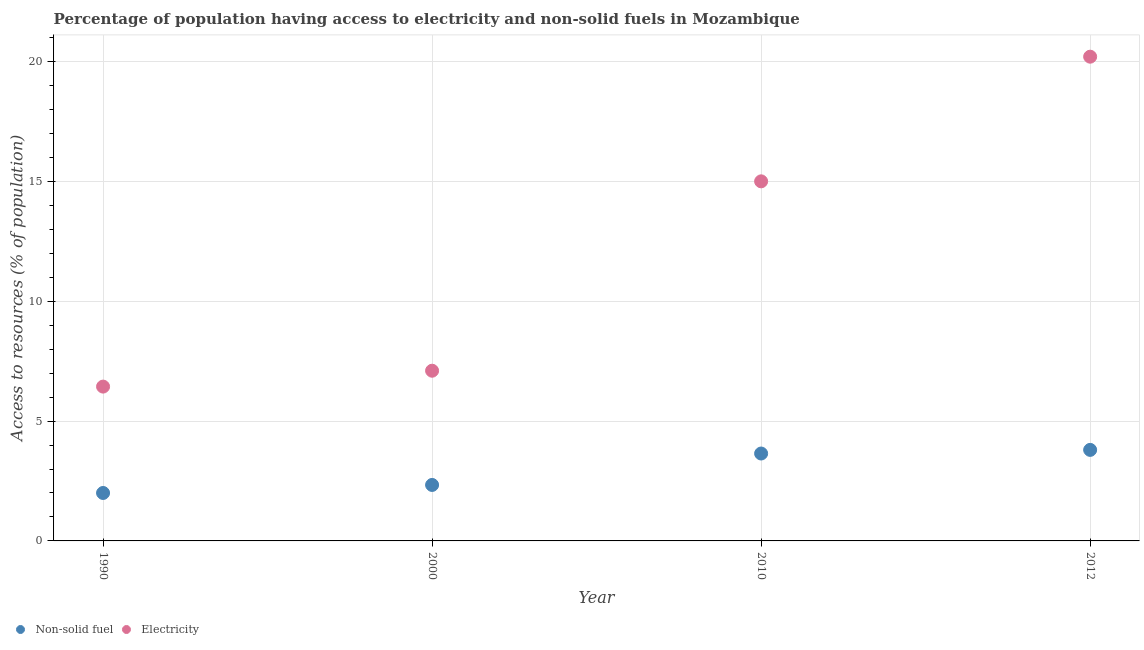Is the number of dotlines equal to the number of legend labels?
Give a very brief answer. Yes. What is the percentage of population having access to electricity in 2010?
Offer a terse response. 15. Across all years, what is the maximum percentage of population having access to electricity?
Offer a very short reply. 20.2. Across all years, what is the minimum percentage of population having access to electricity?
Offer a terse response. 6.44. In which year was the percentage of population having access to non-solid fuel minimum?
Your answer should be very brief. 1990. What is the total percentage of population having access to non-solid fuel in the graph?
Provide a short and direct response. 11.78. What is the difference between the percentage of population having access to electricity in 1990 and that in 2010?
Your answer should be compact. -8.56. What is the difference between the percentage of population having access to non-solid fuel in 1990 and the percentage of population having access to electricity in 2000?
Your answer should be very brief. -5.1. What is the average percentage of population having access to electricity per year?
Your answer should be very brief. 12.18. In the year 1990, what is the difference between the percentage of population having access to electricity and percentage of population having access to non-solid fuel?
Ensure brevity in your answer.  4.44. What is the ratio of the percentage of population having access to electricity in 2000 to that in 2012?
Offer a very short reply. 0.35. What is the difference between the highest and the second highest percentage of population having access to electricity?
Ensure brevity in your answer.  5.2. What is the difference between the highest and the lowest percentage of population having access to electricity?
Your answer should be compact. 13.76. In how many years, is the percentage of population having access to non-solid fuel greater than the average percentage of population having access to non-solid fuel taken over all years?
Your answer should be compact. 2. Does the percentage of population having access to non-solid fuel monotonically increase over the years?
Keep it short and to the point. Yes. Is the percentage of population having access to electricity strictly greater than the percentage of population having access to non-solid fuel over the years?
Provide a short and direct response. Yes. How many dotlines are there?
Ensure brevity in your answer.  2. How many years are there in the graph?
Provide a short and direct response. 4. Does the graph contain any zero values?
Make the answer very short. No. Does the graph contain grids?
Your response must be concise. Yes. What is the title of the graph?
Offer a terse response. Percentage of population having access to electricity and non-solid fuels in Mozambique. Does "Female entrants" appear as one of the legend labels in the graph?
Make the answer very short. No. What is the label or title of the X-axis?
Make the answer very short. Year. What is the label or title of the Y-axis?
Ensure brevity in your answer.  Access to resources (% of population). What is the Access to resources (% of population) in Non-solid fuel in 1990?
Offer a very short reply. 2. What is the Access to resources (% of population) of Electricity in 1990?
Ensure brevity in your answer.  6.44. What is the Access to resources (% of population) in Non-solid fuel in 2000?
Offer a terse response. 2.34. What is the Access to resources (% of population) of Electricity in 2000?
Offer a very short reply. 7.1. What is the Access to resources (% of population) of Non-solid fuel in 2010?
Offer a terse response. 3.65. What is the Access to resources (% of population) in Electricity in 2010?
Your response must be concise. 15. What is the Access to resources (% of population) in Non-solid fuel in 2012?
Offer a terse response. 3.8. What is the Access to resources (% of population) in Electricity in 2012?
Your answer should be very brief. 20.2. Across all years, what is the maximum Access to resources (% of population) in Non-solid fuel?
Offer a very short reply. 3.8. Across all years, what is the maximum Access to resources (% of population) in Electricity?
Provide a short and direct response. 20.2. Across all years, what is the minimum Access to resources (% of population) in Non-solid fuel?
Ensure brevity in your answer.  2. Across all years, what is the minimum Access to resources (% of population) in Electricity?
Your response must be concise. 6.44. What is the total Access to resources (% of population) of Non-solid fuel in the graph?
Provide a succinct answer. 11.78. What is the total Access to resources (% of population) in Electricity in the graph?
Ensure brevity in your answer.  48.74. What is the difference between the Access to resources (% of population) of Non-solid fuel in 1990 and that in 2000?
Give a very brief answer. -0.34. What is the difference between the Access to resources (% of population) in Electricity in 1990 and that in 2000?
Provide a succinct answer. -0.66. What is the difference between the Access to resources (% of population) of Non-solid fuel in 1990 and that in 2010?
Your answer should be compact. -1.65. What is the difference between the Access to resources (% of population) in Electricity in 1990 and that in 2010?
Make the answer very short. -8.56. What is the difference between the Access to resources (% of population) in Non-solid fuel in 1990 and that in 2012?
Offer a terse response. -1.8. What is the difference between the Access to resources (% of population) in Electricity in 1990 and that in 2012?
Your response must be concise. -13.76. What is the difference between the Access to resources (% of population) in Non-solid fuel in 2000 and that in 2010?
Your response must be concise. -1.31. What is the difference between the Access to resources (% of population) in Electricity in 2000 and that in 2010?
Your answer should be compact. -7.9. What is the difference between the Access to resources (% of population) of Non-solid fuel in 2000 and that in 2012?
Keep it short and to the point. -1.46. What is the difference between the Access to resources (% of population) in Electricity in 2000 and that in 2012?
Make the answer very short. -13.1. What is the difference between the Access to resources (% of population) of Non-solid fuel in 2010 and that in 2012?
Offer a terse response. -0.15. What is the difference between the Access to resources (% of population) of Electricity in 2010 and that in 2012?
Make the answer very short. -5.2. What is the difference between the Access to resources (% of population) in Non-solid fuel in 1990 and the Access to resources (% of population) in Electricity in 2000?
Give a very brief answer. -5.1. What is the difference between the Access to resources (% of population) of Non-solid fuel in 1990 and the Access to resources (% of population) of Electricity in 2012?
Your answer should be compact. -18.2. What is the difference between the Access to resources (% of population) of Non-solid fuel in 2000 and the Access to resources (% of population) of Electricity in 2010?
Offer a terse response. -12.66. What is the difference between the Access to resources (% of population) in Non-solid fuel in 2000 and the Access to resources (% of population) in Electricity in 2012?
Offer a terse response. -17.86. What is the difference between the Access to resources (% of population) in Non-solid fuel in 2010 and the Access to resources (% of population) in Electricity in 2012?
Make the answer very short. -16.55. What is the average Access to resources (% of population) in Non-solid fuel per year?
Give a very brief answer. 2.94. What is the average Access to resources (% of population) of Electricity per year?
Provide a short and direct response. 12.18. In the year 1990, what is the difference between the Access to resources (% of population) of Non-solid fuel and Access to resources (% of population) of Electricity?
Provide a succinct answer. -4.44. In the year 2000, what is the difference between the Access to resources (% of population) in Non-solid fuel and Access to resources (% of population) in Electricity?
Ensure brevity in your answer.  -4.76. In the year 2010, what is the difference between the Access to resources (% of population) of Non-solid fuel and Access to resources (% of population) of Electricity?
Offer a terse response. -11.35. In the year 2012, what is the difference between the Access to resources (% of population) in Non-solid fuel and Access to resources (% of population) in Electricity?
Ensure brevity in your answer.  -16.4. What is the ratio of the Access to resources (% of population) of Non-solid fuel in 1990 to that in 2000?
Your response must be concise. 0.86. What is the ratio of the Access to resources (% of population) in Electricity in 1990 to that in 2000?
Offer a terse response. 0.91. What is the ratio of the Access to resources (% of population) of Non-solid fuel in 1990 to that in 2010?
Your response must be concise. 0.55. What is the ratio of the Access to resources (% of population) of Electricity in 1990 to that in 2010?
Make the answer very short. 0.43. What is the ratio of the Access to resources (% of population) in Non-solid fuel in 1990 to that in 2012?
Give a very brief answer. 0.53. What is the ratio of the Access to resources (% of population) of Electricity in 1990 to that in 2012?
Your answer should be compact. 0.32. What is the ratio of the Access to resources (% of population) in Non-solid fuel in 2000 to that in 2010?
Ensure brevity in your answer.  0.64. What is the ratio of the Access to resources (% of population) of Electricity in 2000 to that in 2010?
Make the answer very short. 0.47. What is the ratio of the Access to resources (% of population) in Non-solid fuel in 2000 to that in 2012?
Your response must be concise. 0.61. What is the ratio of the Access to resources (% of population) of Electricity in 2000 to that in 2012?
Offer a very short reply. 0.35. What is the ratio of the Access to resources (% of population) of Non-solid fuel in 2010 to that in 2012?
Offer a terse response. 0.96. What is the ratio of the Access to resources (% of population) in Electricity in 2010 to that in 2012?
Ensure brevity in your answer.  0.74. What is the difference between the highest and the second highest Access to resources (% of population) of Non-solid fuel?
Keep it short and to the point. 0.15. What is the difference between the highest and the second highest Access to resources (% of population) of Electricity?
Give a very brief answer. 5.2. What is the difference between the highest and the lowest Access to resources (% of population) in Non-solid fuel?
Your response must be concise. 1.8. What is the difference between the highest and the lowest Access to resources (% of population) of Electricity?
Your response must be concise. 13.76. 